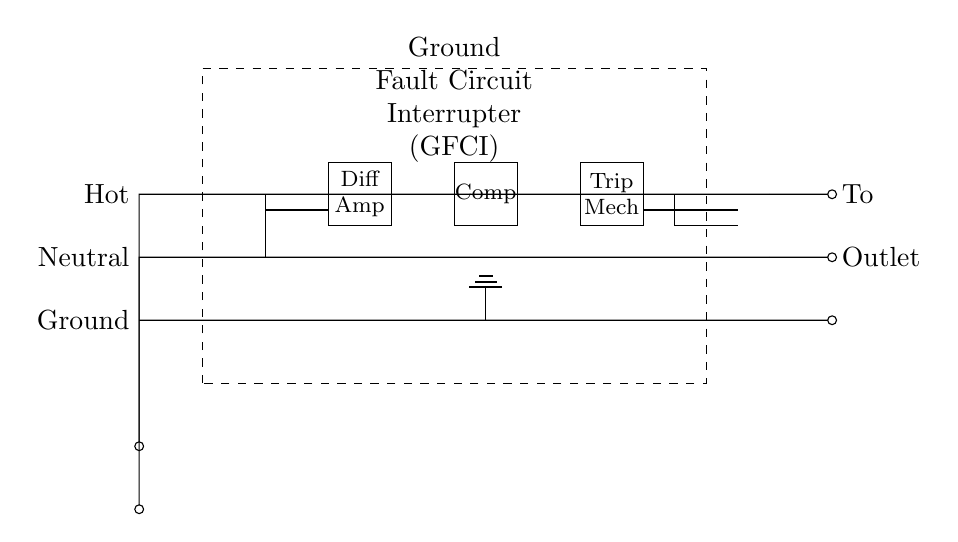What is the function of the GFCI? The GFCI, or Ground Fault Circuit Interrupter, is designed to prevent electric shock by detecting ground faults and interrupting the electrical circuit.
Answer: To prevent electric shock Where is the GFCI located in the circuit? The GFCI is the rectangular dashed box in the middle of the diagram, which represents the GFCI device.
Answer: In the middle How many components are used in the GFCI block? The GFCI diagram contains three components: the differential amplifier, the comparator, and the trip mechanism.
Answer: Three What type of current does the GFCI monitor? The GFCI monitors ground faults by comparing the hot and neutral currents to detect imbalances.
Answer: Ground fault What do the labels "Hot" and "Neutral" represent? "Hot" refers to the live wire that carries electrical current, while "Neutral" is the return path for the current in the circuit.
Answer: Live and return What happens when a ground fault is detected? When a ground fault is detected, the GFCI's trip mechanism activates, cutting off the electrical supply to prevent danger.
Answer: Electrical supply is cut off 